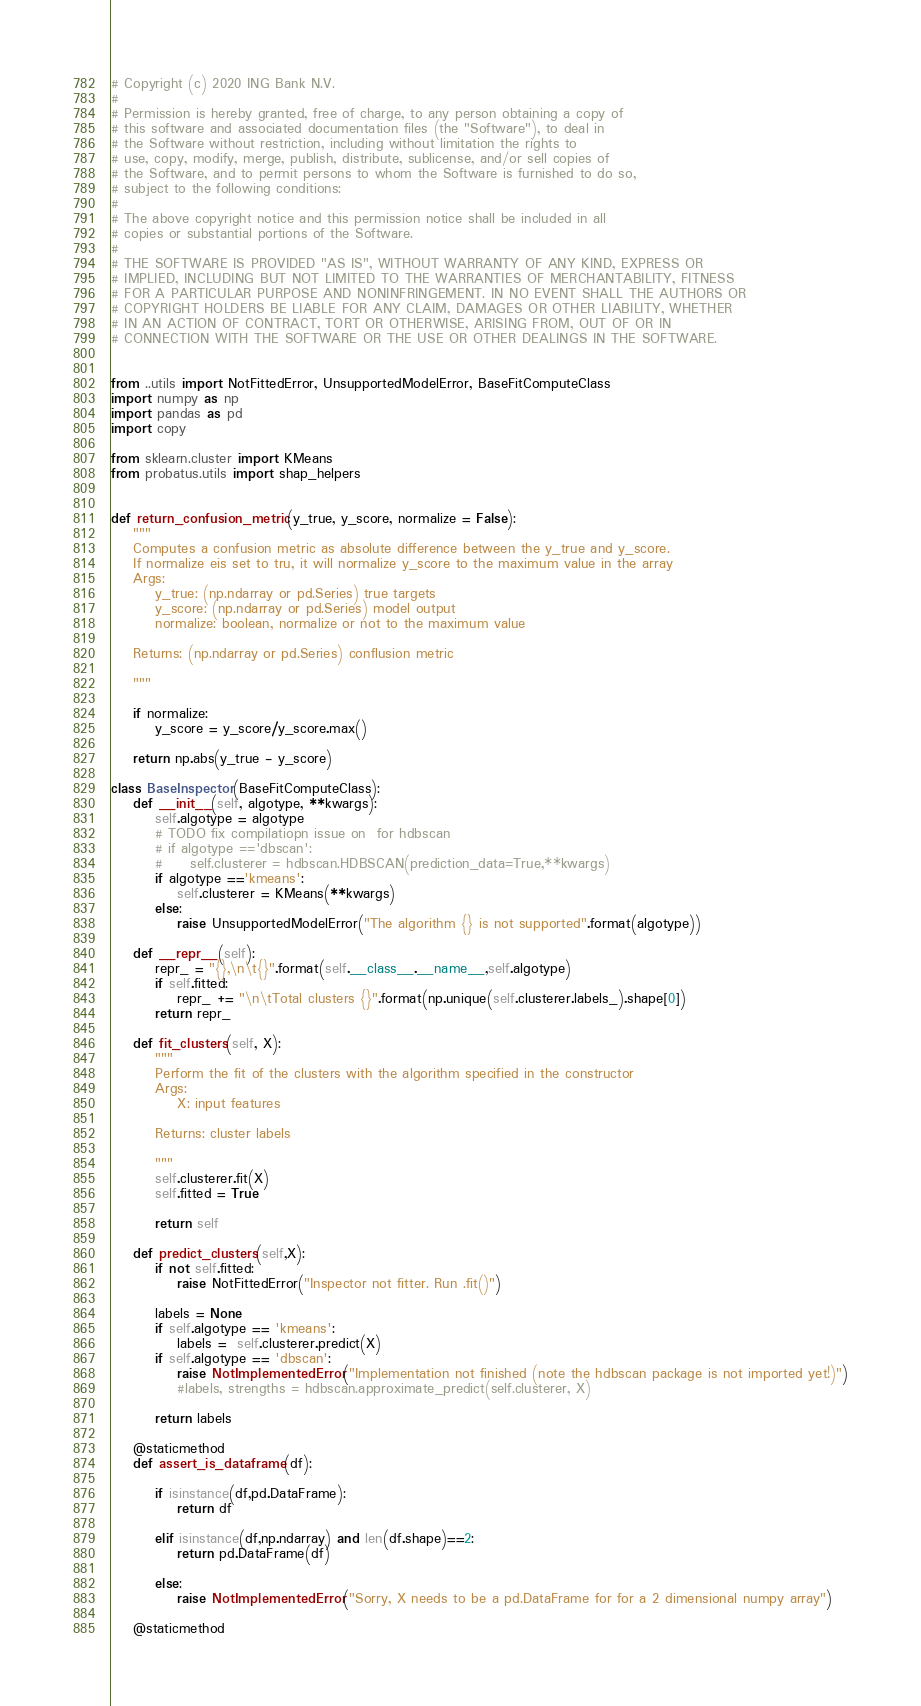Convert code to text. <code><loc_0><loc_0><loc_500><loc_500><_Python_># Copyright (c) 2020 ING Bank N.V.
#
# Permission is hereby granted, free of charge, to any person obtaining a copy of
# this software and associated documentation files (the "Software"), to deal in
# the Software without restriction, including without limitation the rights to
# use, copy, modify, merge, publish, distribute, sublicense, and/or sell copies of
# the Software, and to permit persons to whom the Software is furnished to do so,
# subject to the following conditions:
#
# The above copyright notice and this permission notice shall be included in all
# copies or substantial portions of the Software.
#
# THE SOFTWARE IS PROVIDED "AS IS", WITHOUT WARRANTY OF ANY KIND, EXPRESS OR
# IMPLIED, INCLUDING BUT NOT LIMITED TO THE WARRANTIES OF MERCHANTABILITY, FITNESS
# FOR A PARTICULAR PURPOSE AND NONINFRINGEMENT. IN NO EVENT SHALL THE AUTHORS OR
# COPYRIGHT HOLDERS BE LIABLE FOR ANY CLAIM, DAMAGES OR OTHER LIABILITY, WHETHER
# IN AN ACTION OF CONTRACT, TORT OR OTHERWISE, ARISING FROM, OUT OF OR IN
# CONNECTION WITH THE SOFTWARE OR THE USE OR OTHER DEALINGS IN THE SOFTWARE.


from ..utils import NotFittedError, UnsupportedModelError, BaseFitComputeClass
import numpy as np
import pandas as pd
import copy

from sklearn.cluster import KMeans
from probatus.utils import shap_helpers


def return_confusion_metric(y_true, y_score, normalize = False):
    """
    Computes a confusion metric as absolute difference between the y_true and y_score.
    If normalize eis set to tru, it will normalize y_score to the maximum value in the array
    Args:
        y_true: (np.ndarray or pd.Series) true targets
        y_score: (np.ndarray or pd.Series) model output
        normalize: boolean, normalize or not to the maximum value

    Returns: (np.ndarray or pd.Series) conflusion metric

    """

    if normalize:
        y_score = y_score/y_score.max()

    return np.abs(y_true - y_score)

class BaseInspector(BaseFitComputeClass):
    def __init__(self, algotype, **kwargs):
        self.algotype = algotype
        # TODO fix compilatiopn issue on  for hdbscan
        # if algotype =='dbscan':
        #     self.clusterer = hdbscan.HDBSCAN(prediction_data=True,**kwargs)
        if algotype =='kmeans':
            self.clusterer = KMeans(**kwargs)
        else:
            raise UnsupportedModelError("The algorithm {} is not supported".format(algotype))

    def __repr__(self):
        repr_ = "{},\n\t{}".format(self.__class__.__name__,self.algotype)
        if self.fitted:
            repr_ += "\n\tTotal clusters {}".format(np.unique(self.clusterer.labels_).shape[0])
        return repr_

    def fit_clusters(self, X):
        """
        Perform the fit of the clusters with the algorithm specified in the constructor
        Args:
            X: input features

        Returns: cluster labels

        """
        self.clusterer.fit(X)
        self.fitted = True

        return self

    def predict_clusters(self,X):
        if not self.fitted:
            raise NotFittedError("Inspector not fitter. Run .fit()")

        labels = None
        if self.algotype == 'kmeans':
            labels =  self.clusterer.predict(X)
        if self.algotype == 'dbscan':
            raise NotImplementedError("Implementation not finished (note the hdbscan package is not imported yet!)")
            #labels, strengths = hdbscan.approximate_predict(self.clusterer, X)

        return labels

    @staticmethod
    def assert_is_dataframe(df):

        if isinstance(df,pd.DataFrame):
            return df

        elif isinstance(df,np.ndarray) and len(df.shape)==2:
            return pd.DataFrame(df)

        else:
            raise NotImplementedError("Sorry, X needs to be a pd.DataFrame for for a 2 dimensional numpy array")

    @staticmethod</code> 